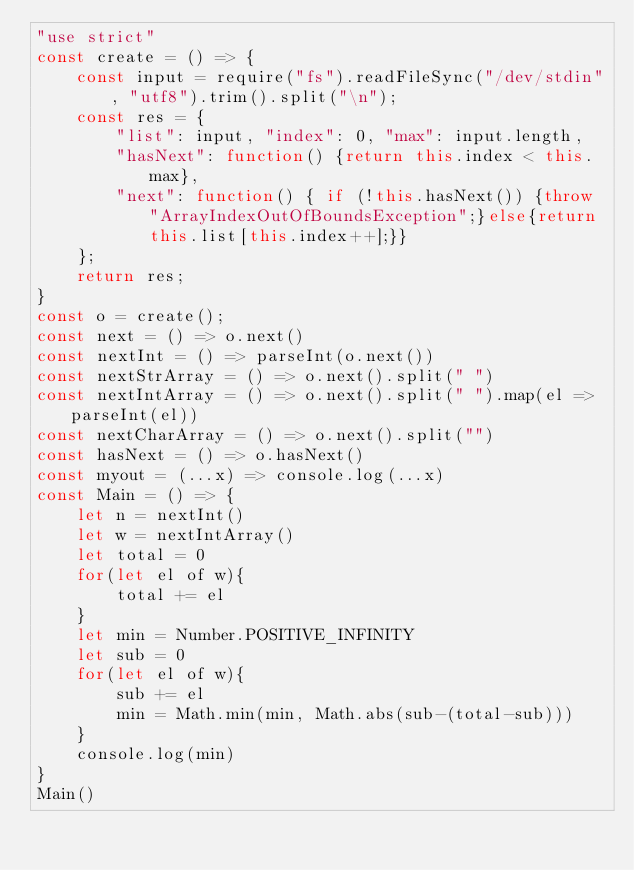Convert code to text. <code><loc_0><loc_0><loc_500><loc_500><_JavaScript_>"use strict"
const create = () => {
    const input = require("fs").readFileSync("/dev/stdin", "utf8").trim().split("\n");
    const res = {
        "list": input, "index": 0, "max": input.length,
        "hasNext": function() {return this.index < this.max},
        "next": function() { if (!this.hasNext()) {throw "ArrayIndexOutOfBoundsException";}else{return this.list[this.index++];}}
    };
    return res;
}
const o = create();
const next = () => o.next()
const nextInt = () => parseInt(o.next())
const nextStrArray = () => o.next().split(" ")
const nextIntArray = () => o.next().split(" ").map(el => parseInt(el))
const nextCharArray = () => o.next().split("")
const hasNext = () => o.hasNext()
const myout = (...x) => console.log(...x)
const Main = () => {
    let n = nextInt()
    let w = nextIntArray()
    let total = 0
    for(let el of w){
        total += el
    }
    let min = Number.POSITIVE_INFINITY
    let sub = 0
    for(let el of w){
        sub += el
        min = Math.min(min, Math.abs(sub-(total-sub)))
    }
    console.log(min)
}
Main()
</code> 